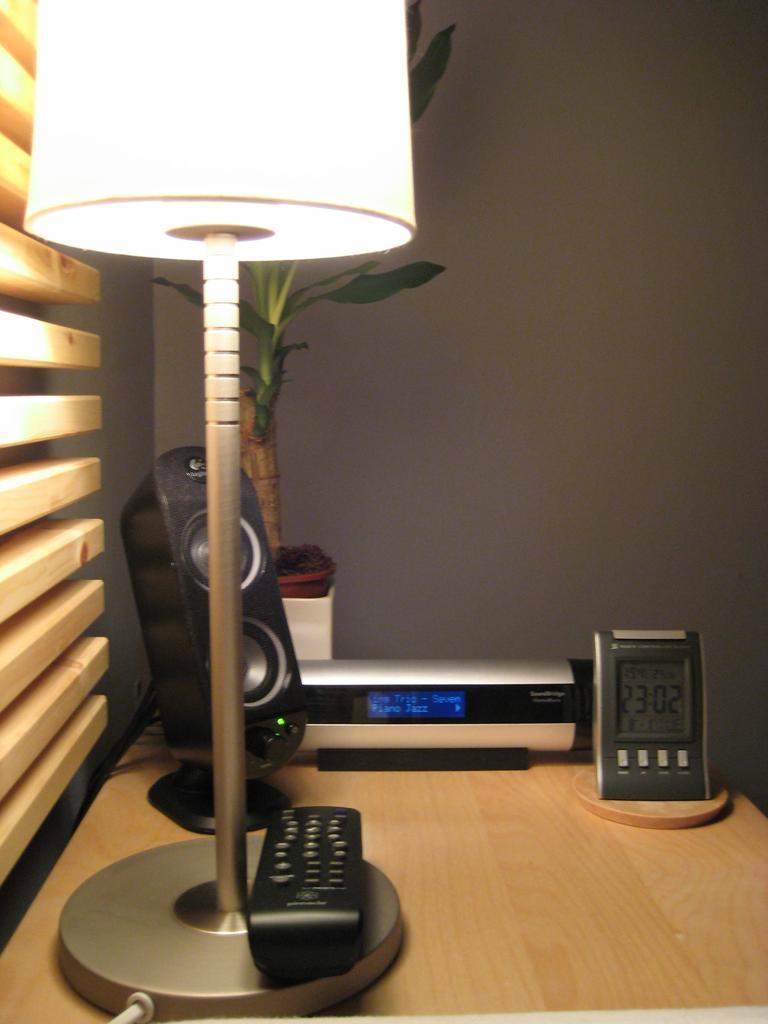Could you give a brief overview of what you see in this image? At the bottom I can see a table on which a lamp, remote, stopwatch, speaker and a houseplant is there. In the background I can see a wall of ash in color. This image is taken in a room. 